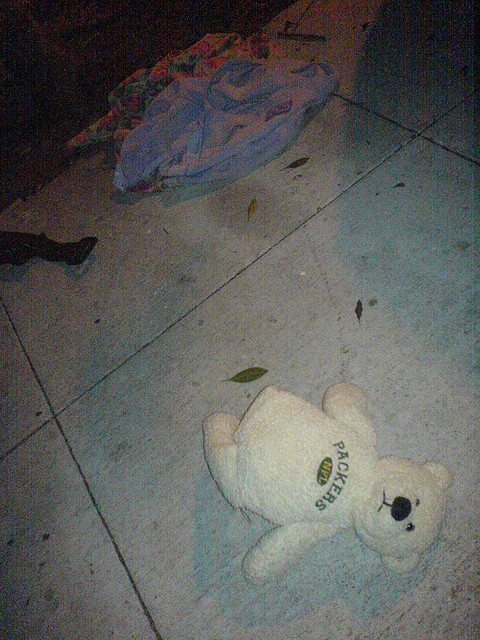Identify the text contained in this image. PACKERS 